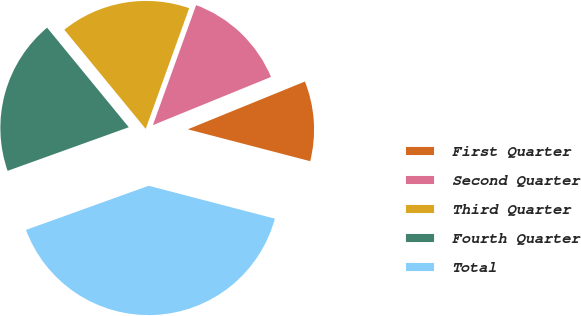Convert chart. <chart><loc_0><loc_0><loc_500><loc_500><pie_chart><fcel>First Quarter<fcel>Second Quarter<fcel>Third Quarter<fcel>Fourth Quarter<fcel>Total<nl><fcel>10.22%<fcel>13.33%<fcel>16.44%<fcel>19.56%<fcel>40.44%<nl></chart> 